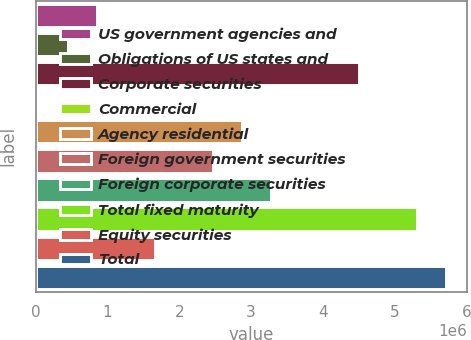Convert chart to OTSL. <chart><loc_0><loc_0><loc_500><loc_500><bar_chart><fcel>US government agencies and<fcel>Obligations of US states and<fcel>Corporate securities<fcel>Commercial<fcel>Agency residential<fcel>Foreign government securities<fcel>Foreign corporate securities<fcel>Total fixed maturity<fcel>Equity securities<fcel>Total<nl><fcel>849468<fcel>443718<fcel>4.50122e+06<fcel>37968<fcel>2.87822e+06<fcel>2.47247e+06<fcel>3.28397e+06<fcel>5.31272e+06<fcel>1.66097e+06<fcel>5.71847e+06<nl></chart> 